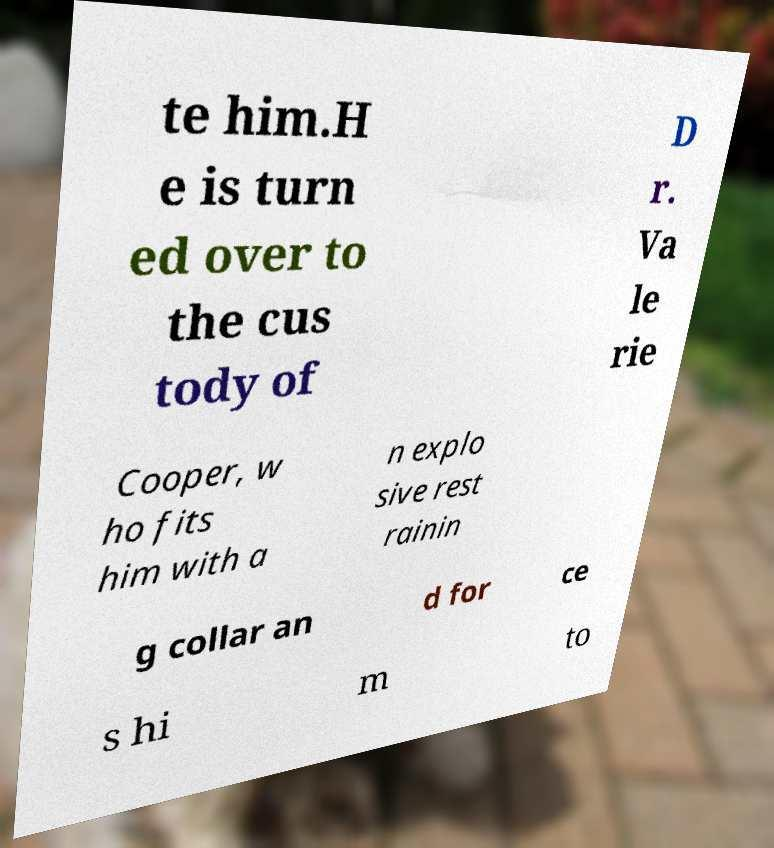For documentation purposes, I need the text within this image transcribed. Could you provide that? te him.H e is turn ed over to the cus tody of D r. Va le rie Cooper, w ho fits him with a n explo sive rest rainin g collar an d for ce s hi m to 